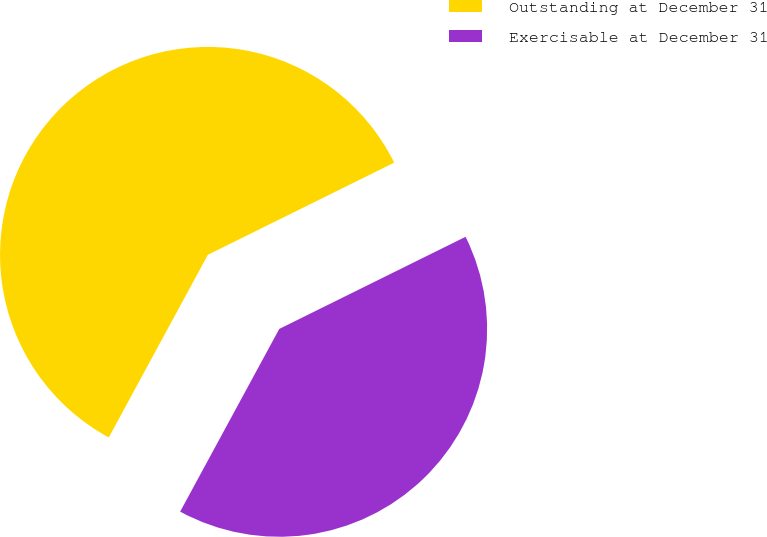<chart> <loc_0><loc_0><loc_500><loc_500><pie_chart><fcel>Outstanding at December 31<fcel>Exercisable at December 31<nl><fcel>59.78%<fcel>40.22%<nl></chart> 